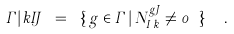<formula> <loc_0><loc_0><loc_500><loc_500>\Gamma | { k } { I } { J } \ = \ \{ \, g \in \Gamma \, | \, N ^ { g J } _ { I \, k } \neq 0 \ \} \ \ .</formula> 